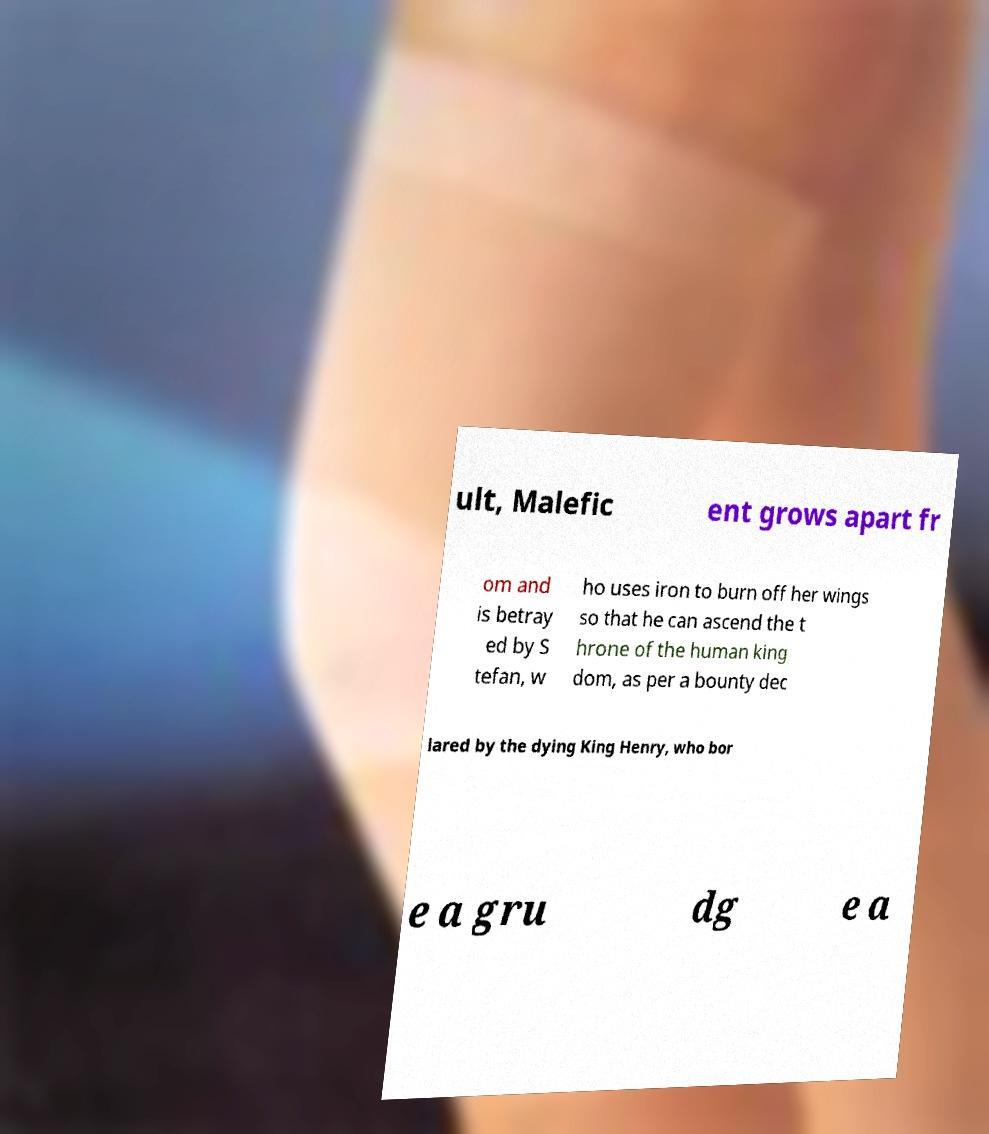I need the written content from this picture converted into text. Can you do that? ult, Malefic ent grows apart fr om and is betray ed by S tefan, w ho uses iron to burn off her wings so that he can ascend the t hrone of the human king dom, as per a bounty dec lared by the dying King Henry, who bor e a gru dg e a 